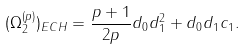<formula> <loc_0><loc_0><loc_500><loc_500>( \Omega _ { 2 } ^ { ( p ) } ) _ { E C H } = \frac { p + 1 } { 2 p } d _ { 0 } d _ { 1 } ^ { 2 } + d _ { 0 } d _ { 1 } c _ { 1 } .</formula> 